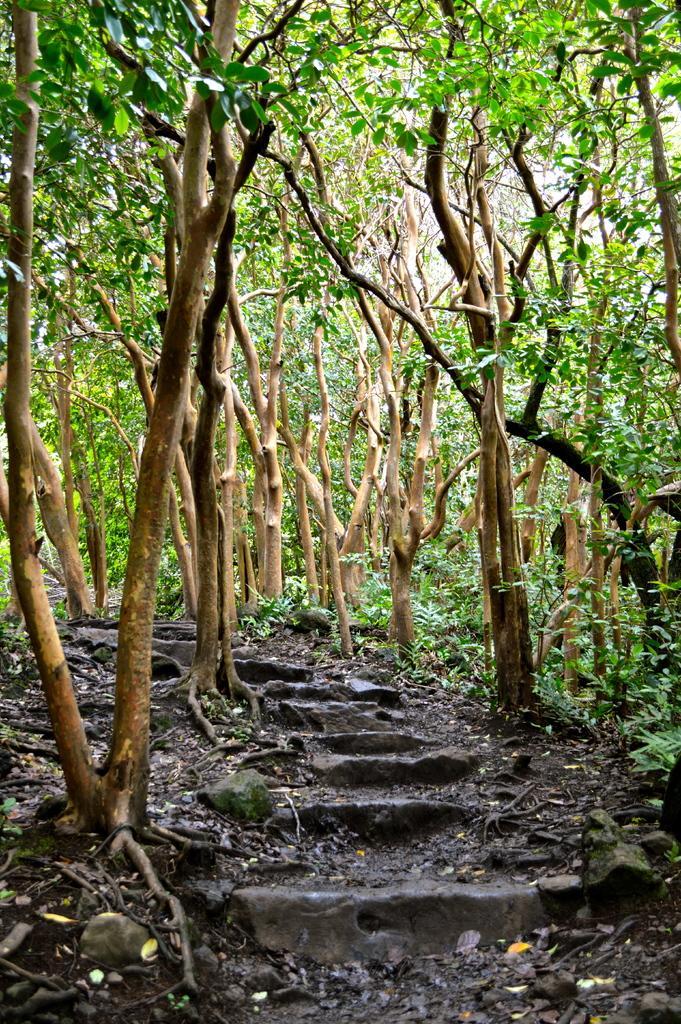Can you describe this image briefly? At the bottom of the image, on the ground there are steps and also there are dry leaves. And in the image there are trees. 